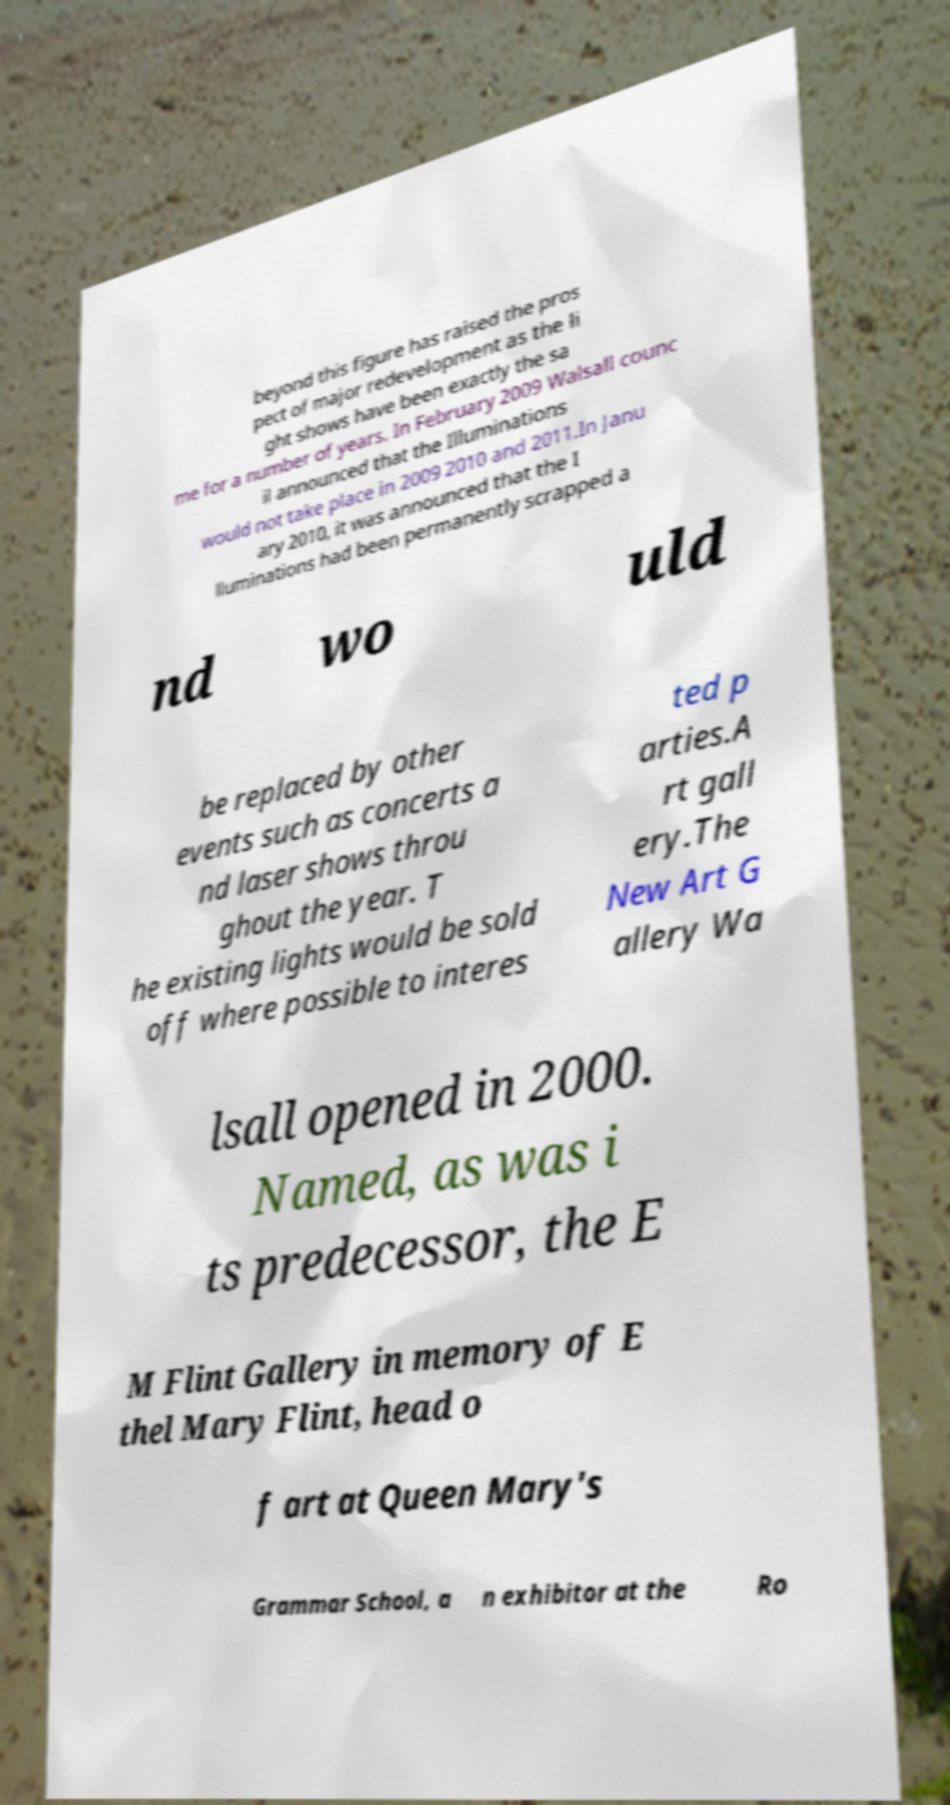Can you read and provide the text displayed in the image?This photo seems to have some interesting text. Can you extract and type it out for me? beyond this figure has raised the pros pect of major redevelopment as the li ght shows have been exactly the sa me for a number of years. In February 2009 Walsall counc il announced that the Illuminations would not take place in 2009 2010 and 2011.In Janu ary 2010, it was announced that the I lluminations had been permanently scrapped a nd wo uld be replaced by other events such as concerts a nd laser shows throu ghout the year. T he existing lights would be sold off where possible to interes ted p arties.A rt gall ery.The New Art G allery Wa lsall opened in 2000. Named, as was i ts predecessor, the E M Flint Gallery in memory of E thel Mary Flint, head o f art at Queen Mary's Grammar School, a n exhibitor at the Ro 